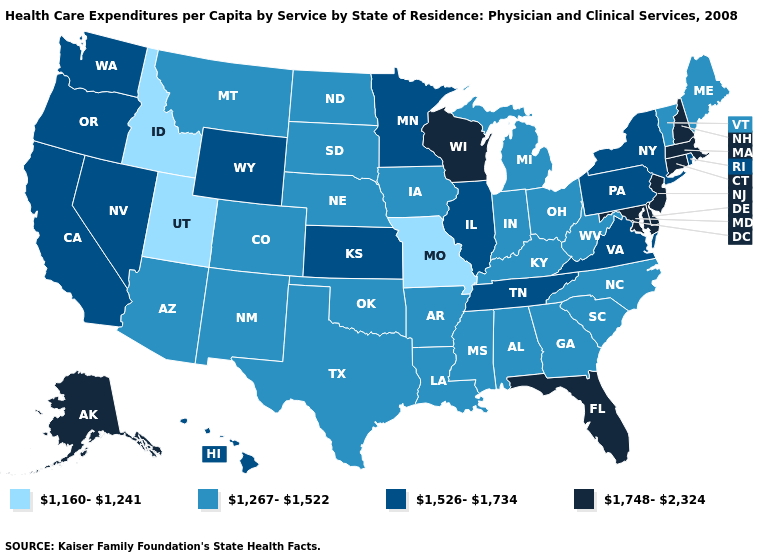Does Utah have the lowest value in the USA?
Be succinct. Yes. Name the states that have a value in the range 1,526-1,734?
Give a very brief answer. California, Hawaii, Illinois, Kansas, Minnesota, Nevada, New York, Oregon, Pennsylvania, Rhode Island, Tennessee, Virginia, Washington, Wyoming. Which states have the lowest value in the USA?
Be succinct. Idaho, Missouri, Utah. Which states have the highest value in the USA?
Answer briefly. Alaska, Connecticut, Delaware, Florida, Maryland, Massachusetts, New Hampshire, New Jersey, Wisconsin. Which states hav the highest value in the MidWest?
Give a very brief answer. Wisconsin. What is the value of Florida?
Give a very brief answer. 1,748-2,324. Which states hav the highest value in the MidWest?
Keep it brief. Wisconsin. What is the value of Alaska?
Be succinct. 1,748-2,324. What is the value of New Jersey?
Quick response, please. 1,748-2,324. Name the states that have a value in the range 1,267-1,522?
Give a very brief answer. Alabama, Arizona, Arkansas, Colorado, Georgia, Indiana, Iowa, Kentucky, Louisiana, Maine, Michigan, Mississippi, Montana, Nebraska, New Mexico, North Carolina, North Dakota, Ohio, Oklahoma, South Carolina, South Dakota, Texas, Vermont, West Virginia. Name the states that have a value in the range 1,267-1,522?
Be succinct. Alabama, Arizona, Arkansas, Colorado, Georgia, Indiana, Iowa, Kentucky, Louisiana, Maine, Michigan, Mississippi, Montana, Nebraska, New Mexico, North Carolina, North Dakota, Ohio, Oklahoma, South Carolina, South Dakota, Texas, Vermont, West Virginia. Which states have the highest value in the USA?
Answer briefly. Alaska, Connecticut, Delaware, Florida, Maryland, Massachusetts, New Hampshire, New Jersey, Wisconsin. Among the states that border Minnesota , which have the highest value?
Concise answer only. Wisconsin. Does Massachusetts have the lowest value in the Northeast?
Answer briefly. No. What is the highest value in the USA?
Write a very short answer. 1,748-2,324. 